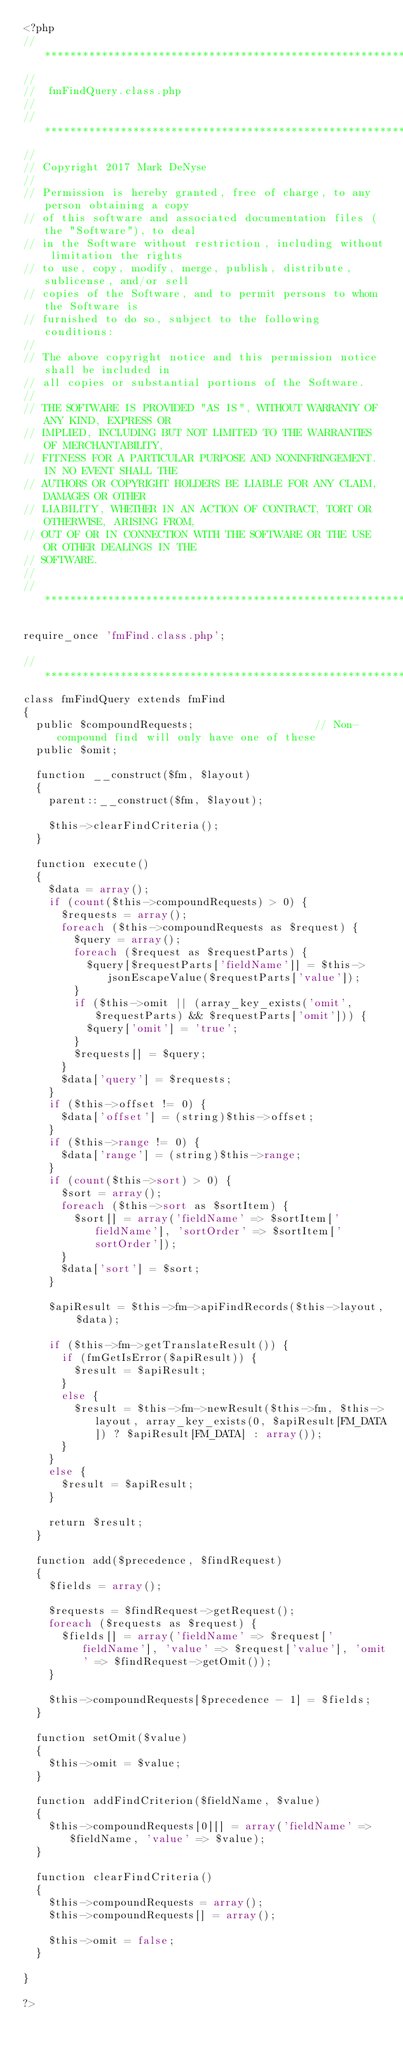Convert code to text. <code><loc_0><loc_0><loc_500><loc_500><_PHP_><?php
// *********************************************************************************************************************************
//
//	fmFindQuery.class.php
//
// *********************************************************************************************************************************
//
// Copyright 2017 Mark DeNyse
//
// Permission is hereby granted, free of charge, to any person obtaining a copy
// of this software and associated documentation files (the "Software"), to deal
// in the Software without restriction, including without limitation the rights
// to use, copy, modify, merge, publish, distribute, sublicense, and/or sell
// copies of the Software, and to permit persons to whom the Software is
// furnished to do so, subject to the following conditions:
//
// The above copyright notice and this permission notice shall be included in
// all copies or substantial portions of the Software.
//
// THE SOFTWARE IS PROVIDED "AS IS", WITHOUT WARRANTY OF ANY KIND, EXPRESS OR
// IMPLIED, INCLUDING BUT NOT LIMITED TO THE WARRANTIES OF MERCHANTABILITY,
// FITNESS FOR A PARTICULAR PURPOSE AND NONINFRINGEMENT. IN NO EVENT SHALL THE
// AUTHORS OR COPYRIGHT HOLDERS BE LIABLE FOR ANY CLAIM, DAMAGES OR OTHER
// LIABILITY, WHETHER IN AN ACTION OF CONTRACT, TORT OR OTHERWISE, ARISING FROM,
// OUT OF OR IN CONNECTION WITH THE SOFTWARE OR THE USE OR OTHER DEALINGS IN THE
// SOFTWARE.
//
// *********************************************************************************************************************************

require_once 'fmFind.class.php';

// *********************************************************************************************************************************
class fmFindQuery extends fmFind
{
	public $compoundRequests;										// Non-compound find will only have one of these
	public $omit;

	function __construct($fm, $layout)
	{
		parent::__construct($fm, $layout);

		$this->clearFindCriteria();
	}

	function execute()
	{
		$data = array();
		if (count($this->compoundRequests) > 0) {
			$requests = array();
			foreach ($this->compoundRequests as $request) {
				$query = array();
				foreach ($request as $requestParts) {
					$query[$requestParts['fieldName']] = $this->jsonEscapeValue($requestParts['value']);
				}
				if ($this->omit || (array_key_exists('omit', $requestParts) && $requestParts['omit'])) {
					$query['omit'] = 'true';
				}
				$requests[] = $query;
			}
			$data['query'] = $requests;
		}
		if ($this->offset != 0) {
			$data['offset'] = (string)$this->offset;
		}
		if ($this->range != 0) {
			$data['range'] = (string)$this->range;
		}
		if (count($this->sort) > 0) {
			$sort = array();
			foreach ($this->sort as $sortItem) {
				$sort[] = array('fieldName' => $sortItem['fieldName'], 'sortOrder' => $sortItem['sortOrder']);
			}
			$data['sort'] = $sort;
		}

		$apiResult = $this->fm->apiFindRecords($this->layout, $data);

		if ($this->fm->getTranslateResult()) {
			if (fmGetIsError($apiResult)) {
				$result = $apiResult;
			}
			else {
				$result = $this->fm->newResult($this->fm, $this->layout, array_key_exists(0, $apiResult[FM_DATA]) ? $apiResult[FM_DATA] : array());
			}
		}
		else {
			$result = $apiResult;
		}

		return $result;
	}

	function add($precedence, $findRequest)
	{
		$fields = array();

		$requests = $findRequest->getRequest();
		foreach ($requests as $request) {
			$fields[] = array('fieldName' => $request['fieldName'], 'value' => $request['value'], 'omit' => $findRequest->getOmit());
		}

		$this->compoundRequests[$precedence - 1] = $fields;
	}

	function setOmit($value)
	{
		$this->omit = $value;
	}

	function addFindCriterion($fieldName, $value)
	{
		$this->compoundRequests[0][] = array('fieldName' => $fieldName, 'value' => $value);
	}

	function clearFindCriteria()
	{
		$this->compoundRequests = array();
		$this->compoundRequests[] = array();

		$this->omit = false;
	}

}

?>
</code> 